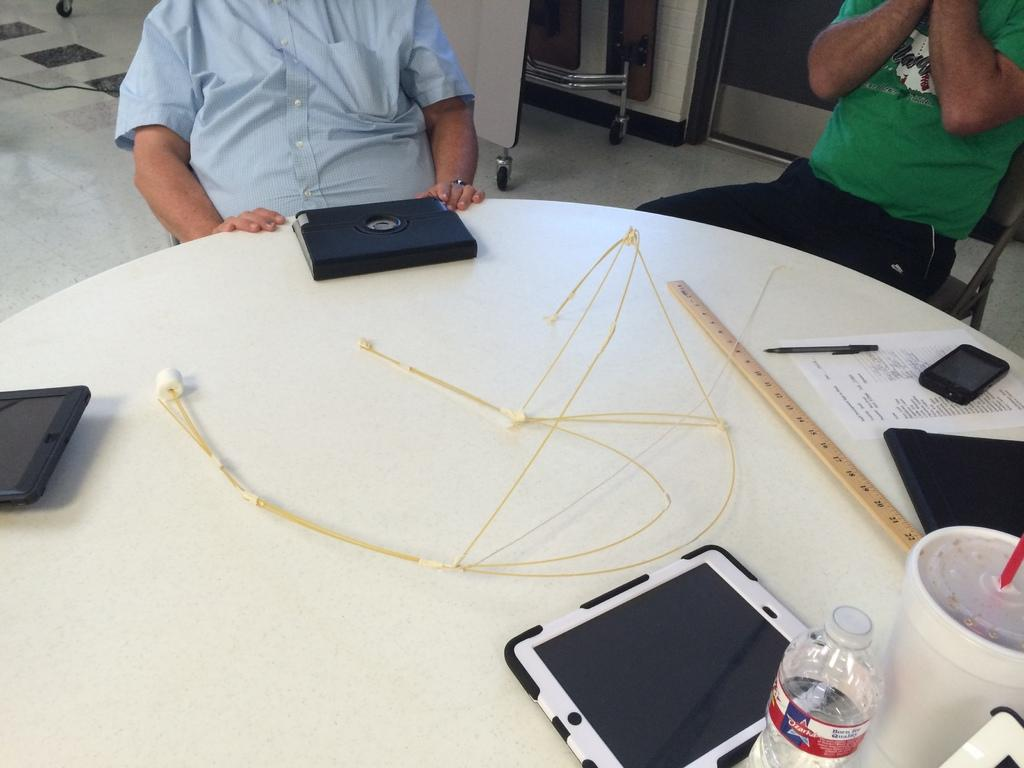How many people are in the image? There are two persons in the image. What are the two persons doing in the image? The two persons are sitting in front of a table. What objects can be seen on the table in the image? The table contains an iPad, a water bottle, a Coke, a scale, a paper, a phone, and a pen. What type of ball is being juggled by the fireman in the image? There is no fireman or ball present in the image. What year is depicted in the image? The image does not depict a specific year; it is a snapshot of a scene with two people sitting at a table. 